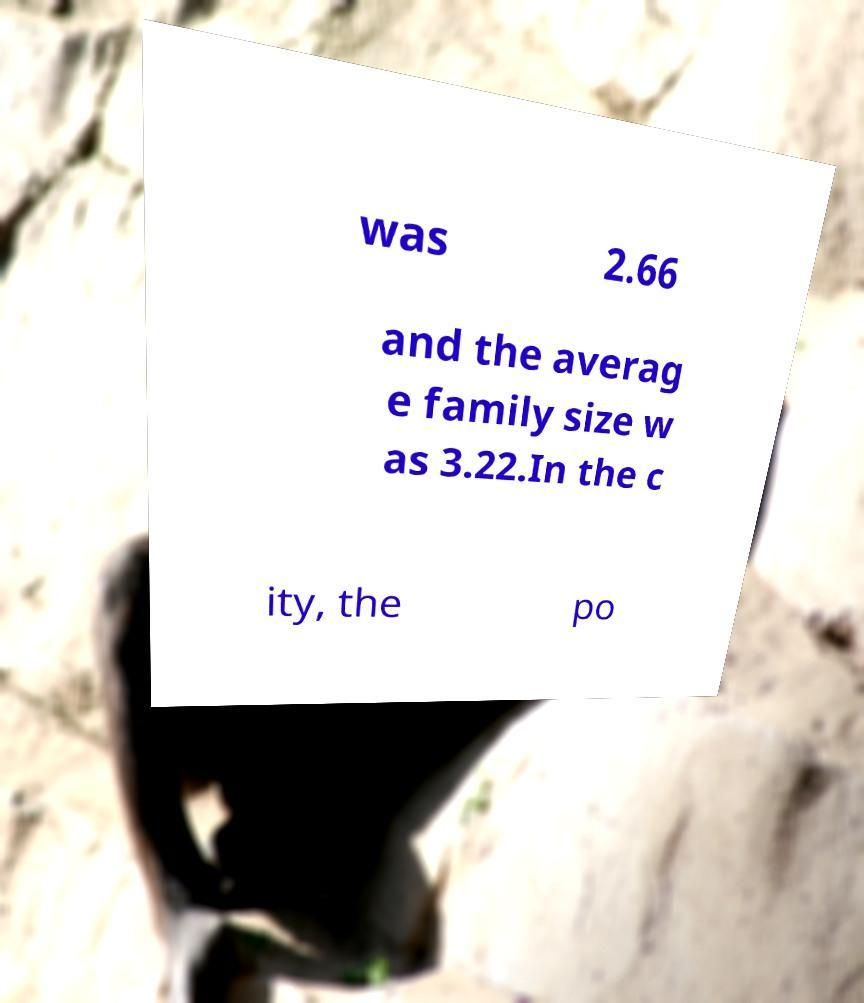Please read and relay the text visible in this image. What does it say? was 2.66 and the averag e family size w as 3.22.In the c ity, the po 